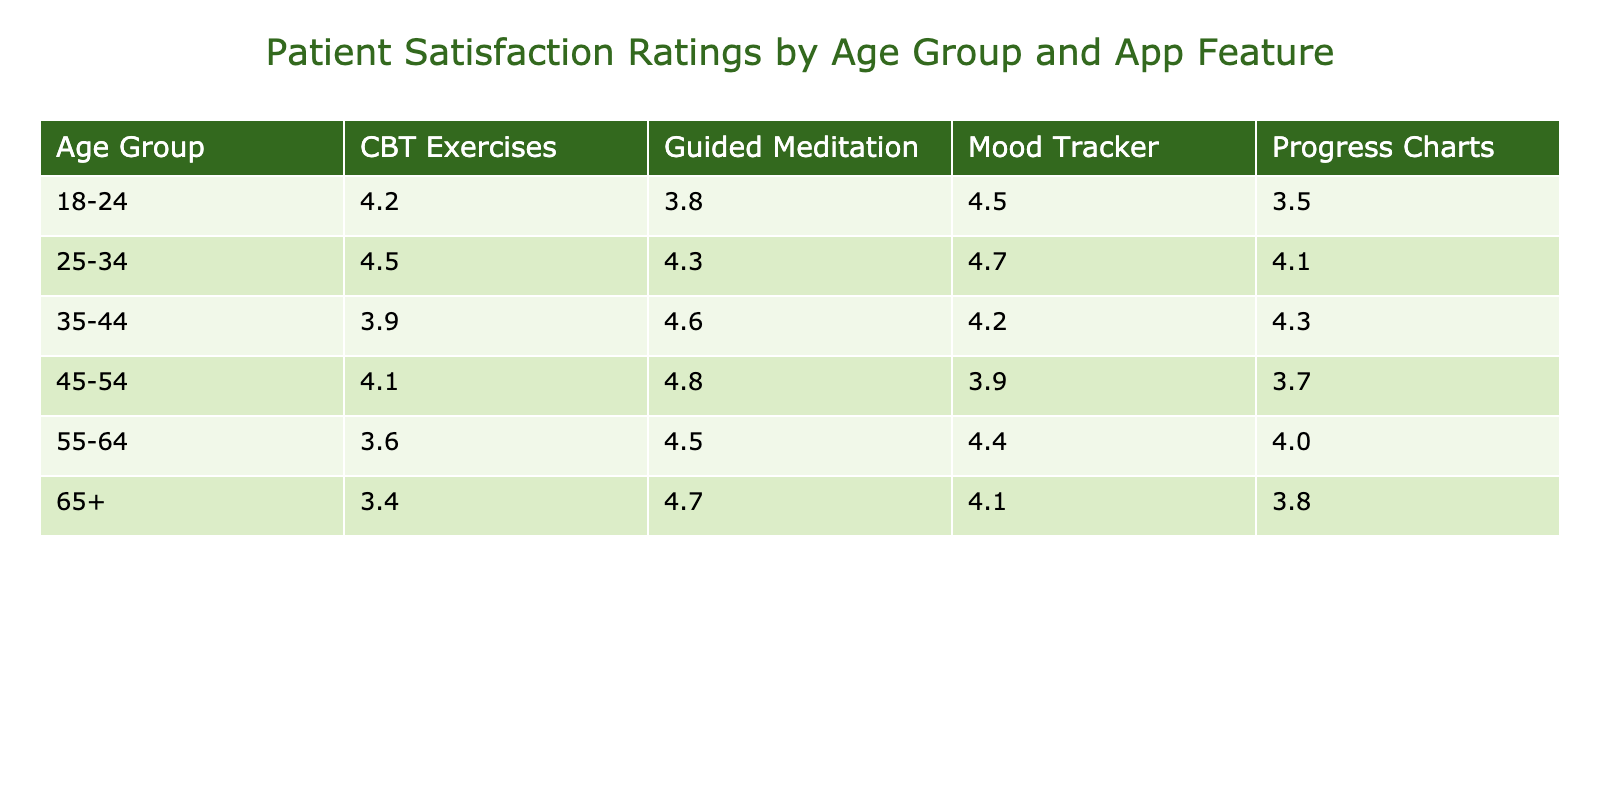What is the satisfaction rating for the Guided Meditation feature among the age group 35-44? From the table, we can look under the "35-44" age group for the "Guided Meditation" feature. The corresponding value is 4.6.
Answer: 4.6 Which app feature has the highest satisfaction rating in the 45-54 age group? We compare the satisfaction ratings for all app features in the "45-54" age group: Mood Tracker (3.9), Guided Meditation (4.8), CBT Exercises (4.1), and Progress Charts (3.7). The highest is 4.8, for Guided Meditation.
Answer: Guided Meditation What is the average satisfaction rating for the Mood Tracker across all age groups? To find the average, we will sum the Mood Tracker ratings from each age group: 4.5 (18-24) + 4.7 (25-34) + 4.2 (35-44) + 3.9 (45-54) + 4.4 (55-64) + 4.1 (65+) = 26.8. There are 6 age groups, so the average is 26.8 / 6 = 4.47.
Answer: 4.5 Is the satisfaction rating for Progress Charts in the 25-34 age group higher than in the 65+ age group? The satisfaction rating for Progress Charts in the "25-34" age group is 4.1, while in the "65+" age group, it is 3.8. Since 4.1 is greater than 3.8, the statement is true.
Answer: Yes How does the average satisfaction rating for CBT Exercises in the 18-24 and 55-64 age groups compare? The rating for 18-24 is 4.2 and for 55-64 is 3.6. We compare these two values directly; since 4.2 > 3.6, the average rating for CBT Exercises is higher in the 18-24 age group.
Answer: 18-24 is higher What is the difference between the highest and lowest satisfaction ratings for app features in the 18-24 age group? The ratings are as follows: Mood Tracker (4.5), Guided Meditation (3.8), CBT Exercises (4.2), Progress Charts (3.5). The highest is 4.5 (Mood Tracker) and the lowest is 3.5 (Progress Charts). The difference is 4.5 - 3.5 = 1.0.
Answer: 1.0 Which age group gives the most positive feedback about the Guided Meditation feature? Evaluating the satisfaction ratings for Guided Meditation: 3.8 (18-24), 4.3 (25-34), 4.6 (35-44), 4.8 (45-54), 4.5 (55-64), 4.7 (65+). The highest rating is 4.8 from the 45-54 age group, indicating the most positive feedback.
Answer: 45-54 What is the satisfaction rating for the Mood Tracker feature for the 25-34 age group, and does it rank higher or lower than the rating for the CBT Exercises in the same group? The Mood Tracker rating for 25-34 is 4.7, while the CBT Exercises rating is 4.5. Since 4.7 > 4.5, the Mood Tracker ranks higher.
Answer: Higher 